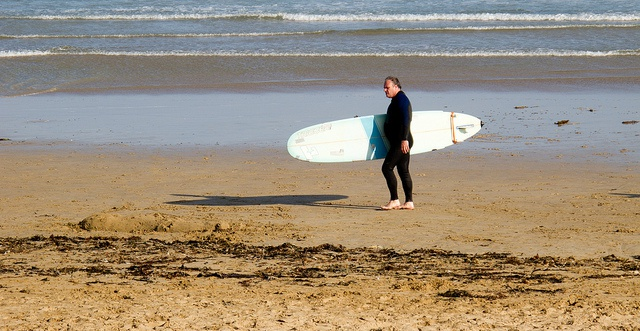Describe the objects in this image and their specific colors. I can see surfboard in gray, ivory, teal, lightblue, and darkgray tones and people in gray, black, tan, and darkgray tones in this image. 